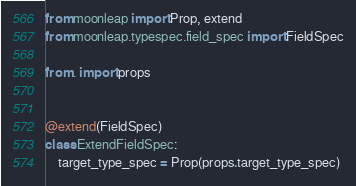<code> <loc_0><loc_0><loc_500><loc_500><_Python_>from moonleap import Prop, extend
from moonleap.typespec.field_spec import FieldSpec

from . import props


@extend(FieldSpec)
class ExtendFieldSpec:
    target_type_spec = Prop(props.target_type_spec)
</code> 